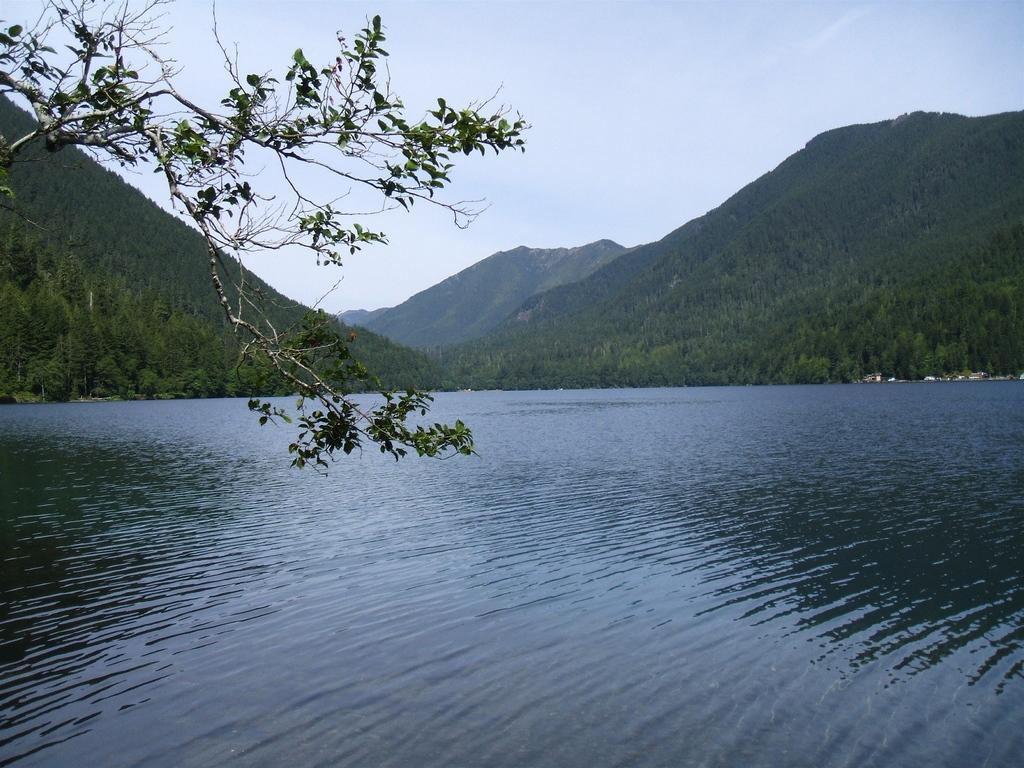Please provide a concise description of this image. In this image we can see the water and there are some trees and we can see the mountains in the background and at the top we can see the sky. 